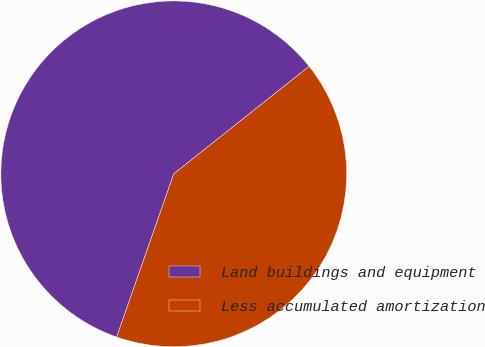Convert chart to OTSL. <chart><loc_0><loc_0><loc_500><loc_500><pie_chart><fcel>Land buildings and equipment<fcel>Less accumulated amortization<nl><fcel>58.96%<fcel>41.04%<nl></chart> 